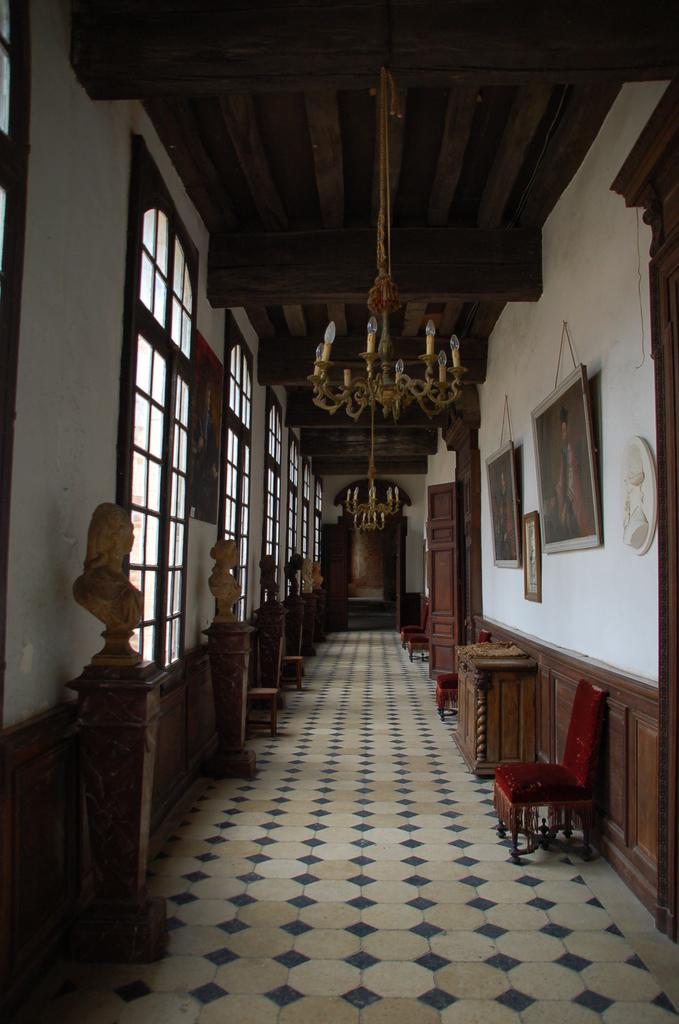Could you give a brief overview of what you see in this image? This is the inside picture of the building. In this image there are statues on the tables. There are chairs. There are wooden doors. There is a wooden table. On the right side of the image there are photo frames on the wall. On the left side of the image there are glass windows. There is a poster attached to the wall. At the bottom of the image there is a floor. In the background of the image there is a wall. On top of the image there are chandeliers. 